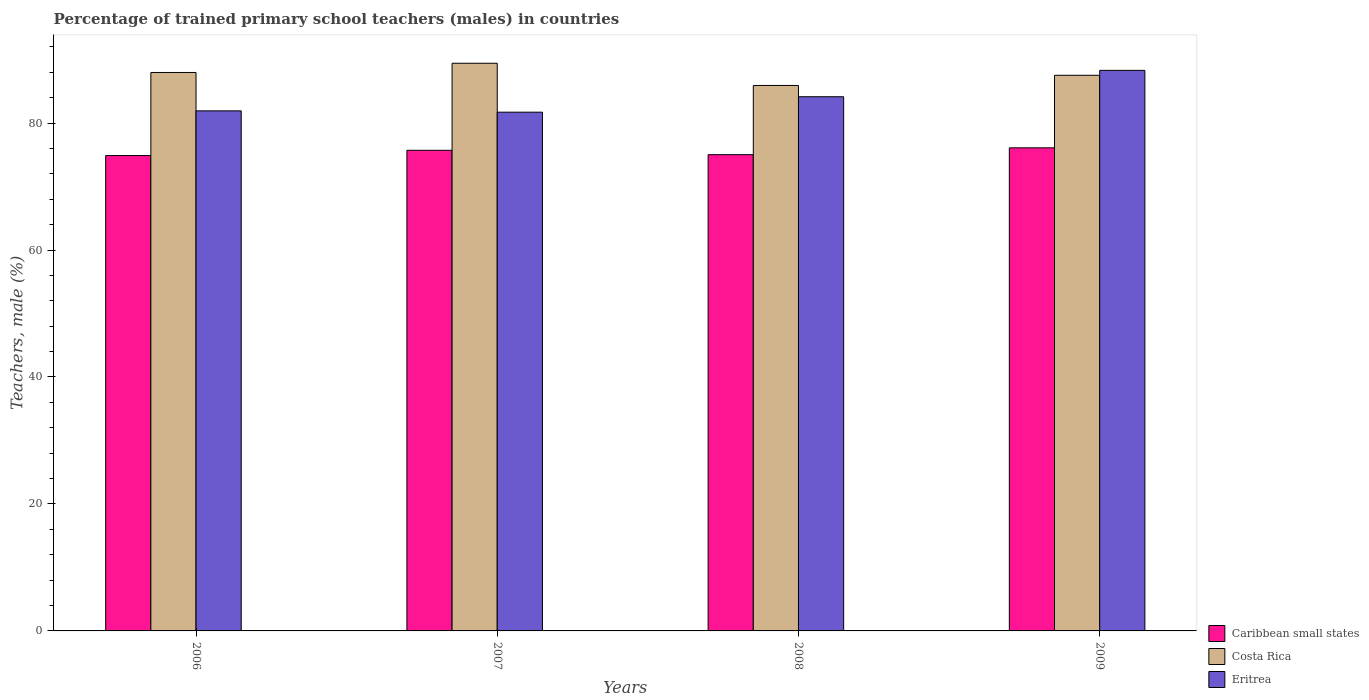Are the number of bars per tick equal to the number of legend labels?
Make the answer very short. Yes. How many bars are there on the 2nd tick from the left?
Keep it short and to the point. 3. In how many cases, is the number of bars for a given year not equal to the number of legend labels?
Offer a very short reply. 0. What is the percentage of trained primary school teachers (males) in Costa Rica in 2009?
Give a very brief answer. 87.52. Across all years, what is the maximum percentage of trained primary school teachers (males) in Eritrea?
Offer a terse response. 88.3. Across all years, what is the minimum percentage of trained primary school teachers (males) in Caribbean small states?
Offer a terse response. 74.88. In which year was the percentage of trained primary school teachers (males) in Caribbean small states maximum?
Your response must be concise. 2009. What is the total percentage of trained primary school teachers (males) in Eritrea in the graph?
Your answer should be compact. 336.06. What is the difference between the percentage of trained primary school teachers (males) in Eritrea in 2006 and that in 2008?
Provide a short and direct response. -2.22. What is the difference between the percentage of trained primary school teachers (males) in Caribbean small states in 2008 and the percentage of trained primary school teachers (males) in Eritrea in 2007?
Ensure brevity in your answer.  -6.69. What is the average percentage of trained primary school teachers (males) in Caribbean small states per year?
Offer a terse response. 75.42. In the year 2009, what is the difference between the percentage of trained primary school teachers (males) in Caribbean small states and percentage of trained primary school teachers (males) in Costa Rica?
Provide a short and direct response. -11.43. What is the ratio of the percentage of trained primary school teachers (males) in Caribbean small states in 2006 to that in 2009?
Your answer should be compact. 0.98. Is the difference between the percentage of trained primary school teachers (males) in Caribbean small states in 2006 and 2009 greater than the difference between the percentage of trained primary school teachers (males) in Costa Rica in 2006 and 2009?
Ensure brevity in your answer.  No. What is the difference between the highest and the second highest percentage of trained primary school teachers (males) in Caribbean small states?
Offer a terse response. 0.39. What is the difference between the highest and the lowest percentage of trained primary school teachers (males) in Caribbean small states?
Ensure brevity in your answer.  1.21. In how many years, is the percentage of trained primary school teachers (males) in Eritrea greater than the average percentage of trained primary school teachers (males) in Eritrea taken over all years?
Ensure brevity in your answer.  2. What does the 2nd bar from the left in 2008 represents?
Keep it short and to the point. Costa Rica. What does the 1st bar from the right in 2006 represents?
Your answer should be compact. Eritrea. Is it the case that in every year, the sum of the percentage of trained primary school teachers (males) in Eritrea and percentage of trained primary school teachers (males) in Caribbean small states is greater than the percentage of trained primary school teachers (males) in Costa Rica?
Offer a very short reply. Yes. Are all the bars in the graph horizontal?
Your answer should be very brief. No. How many years are there in the graph?
Offer a terse response. 4. Are the values on the major ticks of Y-axis written in scientific E-notation?
Offer a very short reply. No. Does the graph contain grids?
Make the answer very short. No. Where does the legend appear in the graph?
Offer a terse response. Bottom right. How many legend labels are there?
Keep it short and to the point. 3. What is the title of the graph?
Keep it short and to the point. Percentage of trained primary school teachers (males) in countries. What is the label or title of the Y-axis?
Make the answer very short. Teachers, male (%). What is the Teachers, male (%) in Caribbean small states in 2006?
Keep it short and to the point. 74.88. What is the Teachers, male (%) of Costa Rica in 2006?
Provide a succinct answer. 87.96. What is the Teachers, male (%) in Eritrea in 2006?
Make the answer very short. 81.92. What is the Teachers, male (%) of Caribbean small states in 2007?
Offer a terse response. 75.7. What is the Teachers, male (%) of Costa Rica in 2007?
Provide a short and direct response. 89.41. What is the Teachers, male (%) of Eritrea in 2007?
Ensure brevity in your answer.  81.71. What is the Teachers, male (%) in Caribbean small states in 2008?
Make the answer very short. 75.01. What is the Teachers, male (%) of Costa Rica in 2008?
Your response must be concise. 85.92. What is the Teachers, male (%) in Eritrea in 2008?
Keep it short and to the point. 84.14. What is the Teachers, male (%) in Caribbean small states in 2009?
Your answer should be very brief. 76.09. What is the Teachers, male (%) in Costa Rica in 2009?
Provide a succinct answer. 87.52. What is the Teachers, male (%) of Eritrea in 2009?
Offer a very short reply. 88.3. Across all years, what is the maximum Teachers, male (%) of Caribbean small states?
Keep it short and to the point. 76.09. Across all years, what is the maximum Teachers, male (%) of Costa Rica?
Offer a very short reply. 89.41. Across all years, what is the maximum Teachers, male (%) of Eritrea?
Your answer should be compact. 88.3. Across all years, what is the minimum Teachers, male (%) of Caribbean small states?
Provide a succinct answer. 74.88. Across all years, what is the minimum Teachers, male (%) in Costa Rica?
Keep it short and to the point. 85.92. Across all years, what is the minimum Teachers, male (%) of Eritrea?
Provide a short and direct response. 81.71. What is the total Teachers, male (%) in Caribbean small states in the graph?
Provide a short and direct response. 301.69. What is the total Teachers, male (%) of Costa Rica in the graph?
Give a very brief answer. 350.81. What is the total Teachers, male (%) of Eritrea in the graph?
Provide a short and direct response. 336.06. What is the difference between the Teachers, male (%) in Caribbean small states in 2006 and that in 2007?
Your response must be concise. -0.83. What is the difference between the Teachers, male (%) in Costa Rica in 2006 and that in 2007?
Your response must be concise. -1.45. What is the difference between the Teachers, male (%) in Eritrea in 2006 and that in 2007?
Offer a terse response. 0.21. What is the difference between the Teachers, male (%) of Caribbean small states in 2006 and that in 2008?
Provide a short and direct response. -0.14. What is the difference between the Teachers, male (%) in Costa Rica in 2006 and that in 2008?
Offer a terse response. 2.05. What is the difference between the Teachers, male (%) of Eritrea in 2006 and that in 2008?
Offer a very short reply. -2.22. What is the difference between the Teachers, male (%) in Caribbean small states in 2006 and that in 2009?
Offer a terse response. -1.21. What is the difference between the Teachers, male (%) of Costa Rica in 2006 and that in 2009?
Offer a very short reply. 0.44. What is the difference between the Teachers, male (%) in Eritrea in 2006 and that in 2009?
Offer a terse response. -6.38. What is the difference between the Teachers, male (%) of Caribbean small states in 2007 and that in 2008?
Your answer should be compact. 0.69. What is the difference between the Teachers, male (%) in Costa Rica in 2007 and that in 2008?
Your answer should be compact. 3.5. What is the difference between the Teachers, male (%) in Eritrea in 2007 and that in 2008?
Your response must be concise. -2.43. What is the difference between the Teachers, male (%) of Caribbean small states in 2007 and that in 2009?
Your answer should be compact. -0.39. What is the difference between the Teachers, male (%) of Costa Rica in 2007 and that in 2009?
Give a very brief answer. 1.89. What is the difference between the Teachers, male (%) in Eritrea in 2007 and that in 2009?
Your answer should be very brief. -6.59. What is the difference between the Teachers, male (%) of Caribbean small states in 2008 and that in 2009?
Offer a terse response. -1.08. What is the difference between the Teachers, male (%) in Costa Rica in 2008 and that in 2009?
Offer a very short reply. -1.6. What is the difference between the Teachers, male (%) in Eritrea in 2008 and that in 2009?
Keep it short and to the point. -4.15. What is the difference between the Teachers, male (%) in Caribbean small states in 2006 and the Teachers, male (%) in Costa Rica in 2007?
Your response must be concise. -14.54. What is the difference between the Teachers, male (%) in Caribbean small states in 2006 and the Teachers, male (%) in Eritrea in 2007?
Provide a succinct answer. -6.83. What is the difference between the Teachers, male (%) of Costa Rica in 2006 and the Teachers, male (%) of Eritrea in 2007?
Provide a short and direct response. 6.25. What is the difference between the Teachers, male (%) of Caribbean small states in 2006 and the Teachers, male (%) of Costa Rica in 2008?
Give a very brief answer. -11.04. What is the difference between the Teachers, male (%) in Caribbean small states in 2006 and the Teachers, male (%) in Eritrea in 2008?
Provide a succinct answer. -9.26. What is the difference between the Teachers, male (%) in Costa Rica in 2006 and the Teachers, male (%) in Eritrea in 2008?
Make the answer very short. 3.82. What is the difference between the Teachers, male (%) of Caribbean small states in 2006 and the Teachers, male (%) of Costa Rica in 2009?
Make the answer very short. -12.64. What is the difference between the Teachers, male (%) of Caribbean small states in 2006 and the Teachers, male (%) of Eritrea in 2009?
Offer a very short reply. -13.42. What is the difference between the Teachers, male (%) in Costa Rica in 2006 and the Teachers, male (%) in Eritrea in 2009?
Your response must be concise. -0.33. What is the difference between the Teachers, male (%) of Caribbean small states in 2007 and the Teachers, male (%) of Costa Rica in 2008?
Your answer should be compact. -10.21. What is the difference between the Teachers, male (%) in Caribbean small states in 2007 and the Teachers, male (%) in Eritrea in 2008?
Your response must be concise. -8.44. What is the difference between the Teachers, male (%) in Costa Rica in 2007 and the Teachers, male (%) in Eritrea in 2008?
Offer a terse response. 5.27. What is the difference between the Teachers, male (%) in Caribbean small states in 2007 and the Teachers, male (%) in Costa Rica in 2009?
Provide a short and direct response. -11.82. What is the difference between the Teachers, male (%) of Caribbean small states in 2007 and the Teachers, male (%) of Eritrea in 2009?
Make the answer very short. -12.59. What is the difference between the Teachers, male (%) in Costa Rica in 2007 and the Teachers, male (%) in Eritrea in 2009?
Give a very brief answer. 1.12. What is the difference between the Teachers, male (%) of Caribbean small states in 2008 and the Teachers, male (%) of Costa Rica in 2009?
Your response must be concise. -12.51. What is the difference between the Teachers, male (%) in Caribbean small states in 2008 and the Teachers, male (%) in Eritrea in 2009?
Provide a short and direct response. -13.28. What is the difference between the Teachers, male (%) in Costa Rica in 2008 and the Teachers, male (%) in Eritrea in 2009?
Provide a short and direct response. -2.38. What is the average Teachers, male (%) of Caribbean small states per year?
Ensure brevity in your answer.  75.42. What is the average Teachers, male (%) of Costa Rica per year?
Your response must be concise. 87.7. What is the average Teachers, male (%) of Eritrea per year?
Provide a succinct answer. 84.02. In the year 2006, what is the difference between the Teachers, male (%) in Caribbean small states and Teachers, male (%) in Costa Rica?
Keep it short and to the point. -13.09. In the year 2006, what is the difference between the Teachers, male (%) in Caribbean small states and Teachers, male (%) in Eritrea?
Your response must be concise. -7.04. In the year 2006, what is the difference between the Teachers, male (%) of Costa Rica and Teachers, male (%) of Eritrea?
Provide a succinct answer. 6.05. In the year 2007, what is the difference between the Teachers, male (%) in Caribbean small states and Teachers, male (%) in Costa Rica?
Offer a very short reply. -13.71. In the year 2007, what is the difference between the Teachers, male (%) of Caribbean small states and Teachers, male (%) of Eritrea?
Keep it short and to the point. -6. In the year 2007, what is the difference between the Teachers, male (%) in Costa Rica and Teachers, male (%) in Eritrea?
Your response must be concise. 7.71. In the year 2008, what is the difference between the Teachers, male (%) of Caribbean small states and Teachers, male (%) of Costa Rica?
Provide a short and direct response. -10.9. In the year 2008, what is the difference between the Teachers, male (%) of Caribbean small states and Teachers, male (%) of Eritrea?
Provide a succinct answer. -9.13. In the year 2008, what is the difference between the Teachers, male (%) in Costa Rica and Teachers, male (%) in Eritrea?
Provide a succinct answer. 1.78. In the year 2009, what is the difference between the Teachers, male (%) in Caribbean small states and Teachers, male (%) in Costa Rica?
Keep it short and to the point. -11.43. In the year 2009, what is the difference between the Teachers, male (%) in Caribbean small states and Teachers, male (%) in Eritrea?
Offer a terse response. -12.2. In the year 2009, what is the difference between the Teachers, male (%) of Costa Rica and Teachers, male (%) of Eritrea?
Your response must be concise. -0.78. What is the ratio of the Teachers, male (%) in Costa Rica in 2006 to that in 2007?
Make the answer very short. 0.98. What is the ratio of the Teachers, male (%) of Eritrea in 2006 to that in 2007?
Your answer should be very brief. 1. What is the ratio of the Teachers, male (%) of Costa Rica in 2006 to that in 2008?
Your response must be concise. 1.02. What is the ratio of the Teachers, male (%) in Eritrea in 2006 to that in 2008?
Offer a terse response. 0.97. What is the ratio of the Teachers, male (%) in Caribbean small states in 2006 to that in 2009?
Your answer should be very brief. 0.98. What is the ratio of the Teachers, male (%) of Eritrea in 2006 to that in 2009?
Offer a very short reply. 0.93. What is the ratio of the Teachers, male (%) in Caribbean small states in 2007 to that in 2008?
Offer a very short reply. 1.01. What is the ratio of the Teachers, male (%) in Costa Rica in 2007 to that in 2008?
Provide a short and direct response. 1.04. What is the ratio of the Teachers, male (%) of Eritrea in 2007 to that in 2008?
Keep it short and to the point. 0.97. What is the ratio of the Teachers, male (%) in Caribbean small states in 2007 to that in 2009?
Ensure brevity in your answer.  0.99. What is the ratio of the Teachers, male (%) in Costa Rica in 2007 to that in 2009?
Keep it short and to the point. 1.02. What is the ratio of the Teachers, male (%) in Eritrea in 2007 to that in 2009?
Provide a succinct answer. 0.93. What is the ratio of the Teachers, male (%) of Caribbean small states in 2008 to that in 2009?
Provide a succinct answer. 0.99. What is the ratio of the Teachers, male (%) of Costa Rica in 2008 to that in 2009?
Keep it short and to the point. 0.98. What is the ratio of the Teachers, male (%) in Eritrea in 2008 to that in 2009?
Provide a succinct answer. 0.95. What is the difference between the highest and the second highest Teachers, male (%) of Caribbean small states?
Your answer should be very brief. 0.39. What is the difference between the highest and the second highest Teachers, male (%) of Costa Rica?
Offer a very short reply. 1.45. What is the difference between the highest and the second highest Teachers, male (%) of Eritrea?
Provide a short and direct response. 4.15. What is the difference between the highest and the lowest Teachers, male (%) of Caribbean small states?
Offer a very short reply. 1.21. What is the difference between the highest and the lowest Teachers, male (%) in Costa Rica?
Keep it short and to the point. 3.5. What is the difference between the highest and the lowest Teachers, male (%) in Eritrea?
Offer a terse response. 6.59. 